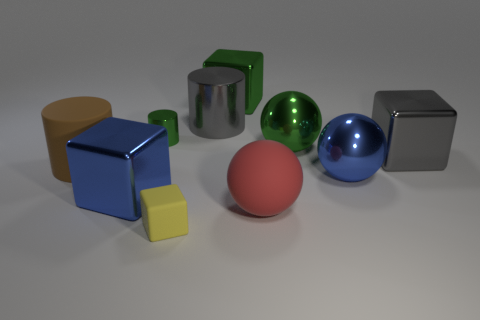What number of cubes are either big blue metallic objects or large red matte things? In the image, there are two cubes: one is a large blue metallic object, and the other is a large red matte cube. So the number of cubes that are either big blue metallic objects or large red matte things is two. 